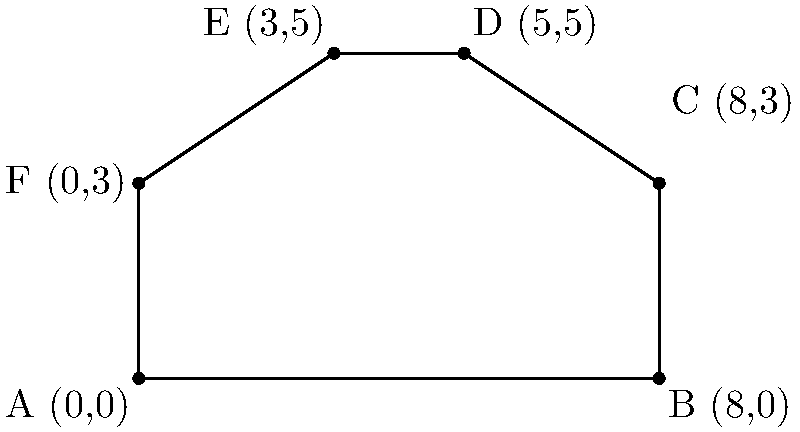As a meticulous entrepreneur, you're designing a custom countertop for your bakery. The countertop has an irregular shape represented by the coordinates A(0,0), B(8,0), C(8,3), D(5,5), E(3,5), and F(0,3) in a coordinate system where each unit represents 1 foot. Calculate the exact area of this countertop in square feet to ensure you order the correct amount of material. To calculate the area of this irregular shape, we can divide it into two triangles and a rectangle:

1. Rectangle ABCF:
   Area = length * width = 8 * 3 = 24 sq ft

2. Triangle CDE:
   Base = 3, Height = 2
   Area = $\frac{1}{2}$ * base * height = $\frac{1}{2}$ * 3 * 2 = 3 sq ft

3. Triangle DEF:
   Base = 3, Height = 2
   Area = $\frac{1}{2}$ * base * height = $\frac{1}{2}$ * 3 * 2 = 3 sq ft

Total Area = Rectangle Area + Triangle CDE Area + Triangle DEF Area
            = 24 + 3 + 3 = 30 sq ft

Therefore, the exact area of the countertop is 30 square feet.
Answer: 30 sq ft 